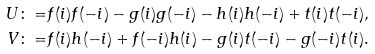Convert formula to latex. <formula><loc_0><loc_0><loc_500><loc_500>U \colon = & f ( i ) f ( - i ) - g ( i ) g ( - i ) - h ( i ) h ( - i ) + t ( i ) t ( - i ) , \\ V \colon = & f ( i ) h ( - i ) + f ( - i ) h ( i ) - g ( i ) t ( - i ) - g ( - i ) t ( i ) .</formula> 